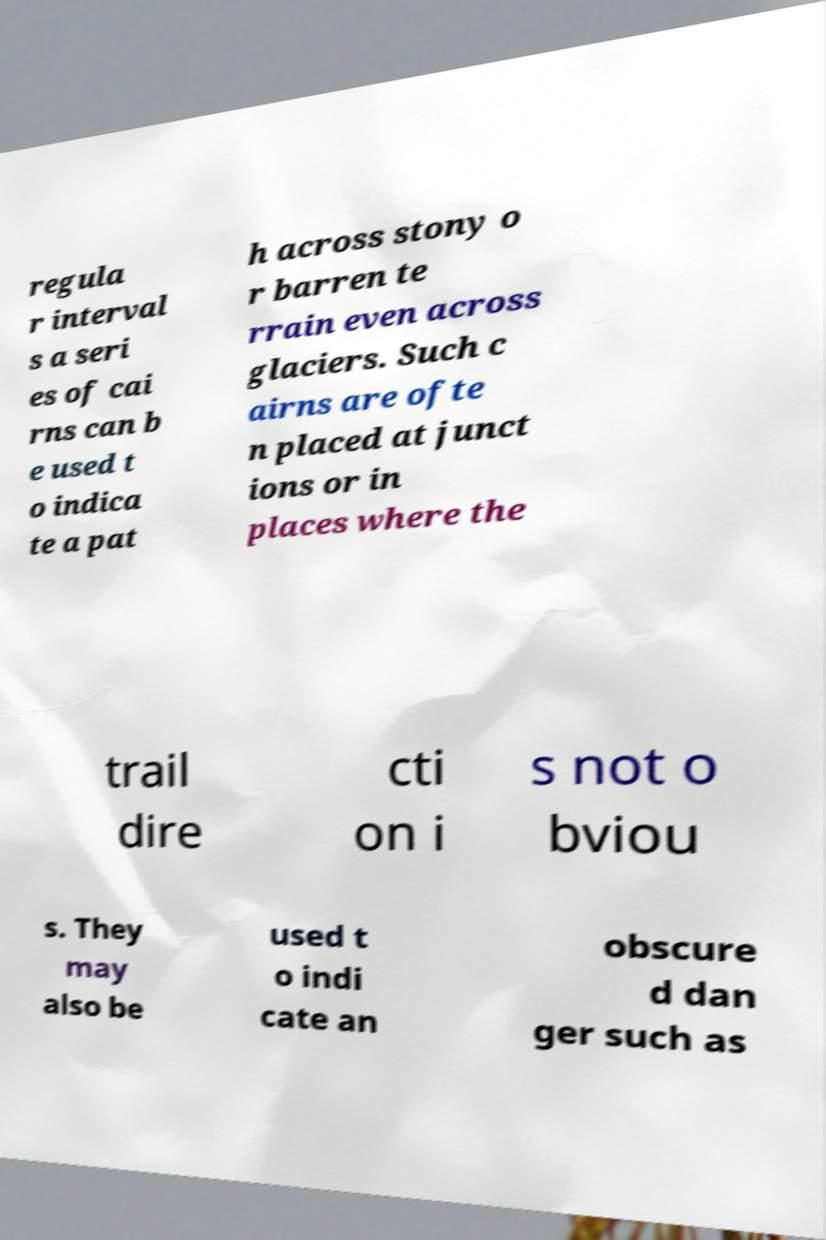Please read and relay the text visible in this image. What does it say? regula r interval s a seri es of cai rns can b e used t o indica te a pat h across stony o r barren te rrain even across glaciers. Such c airns are ofte n placed at junct ions or in places where the trail dire cti on i s not o bviou s. They may also be used t o indi cate an obscure d dan ger such as 